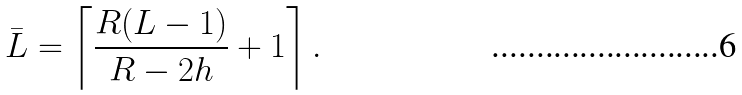<formula> <loc_0><loc_0><loc_500><loc_500>\bar { L } = \left \lceil \frac { R ( L - 1 ) } { R - 2 h } + 1 \right \rceil .</formula> 